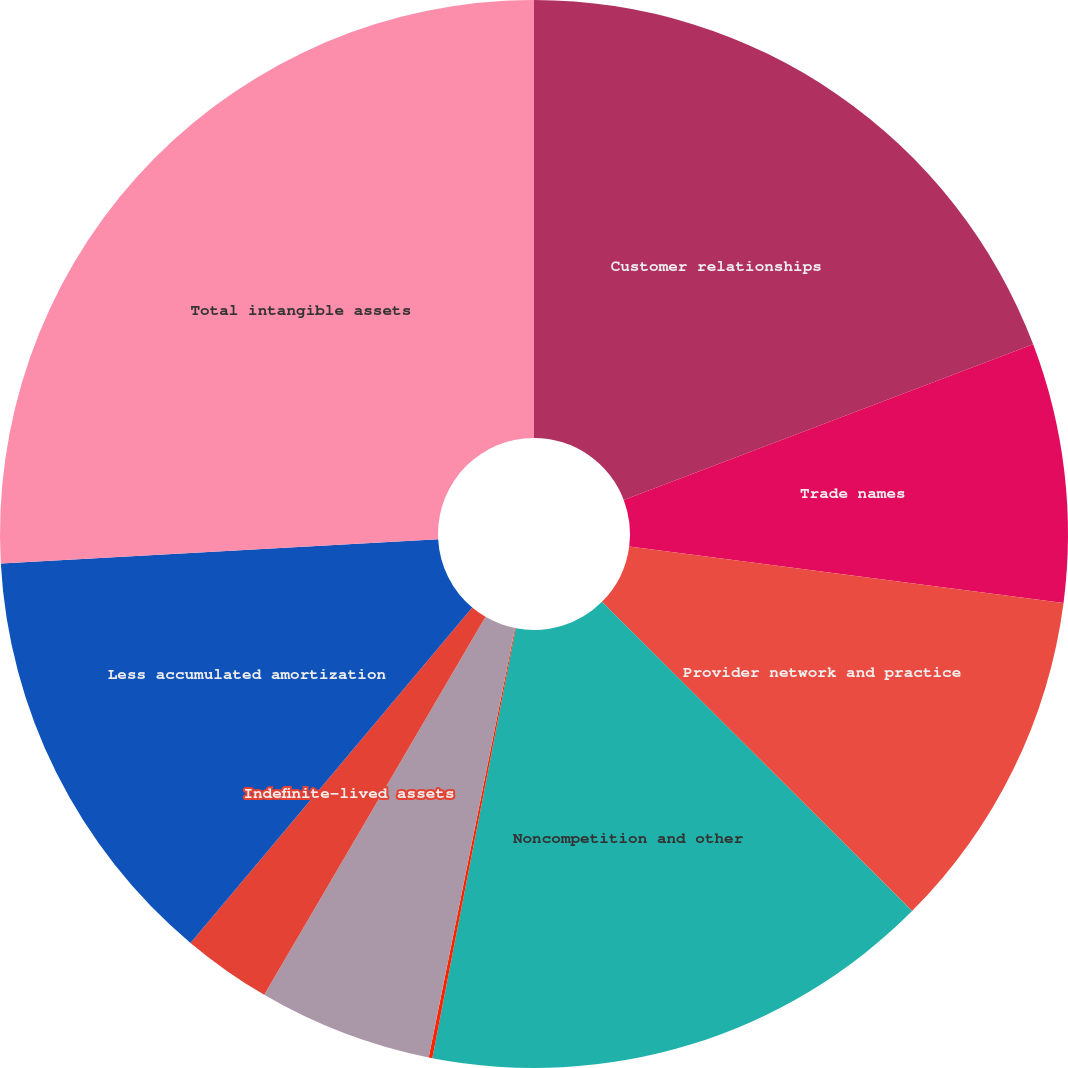<chart> <loc_0><loc_0><loc_500><loc_500><pie_chart><fcel>Customer relationships<fcel>Trade names<fcel>Provider network and practice<fcel>Noncompetition and other<fcel>Lease agreements<fcel>Deferred debt financing costs<fcel>Indefinite-lived assets<fcel>Less accumulated amortization<fcel>Total intangible assets<nl><fcel>19.22%<fcel>7.84%<fcel>10.42%<fcel>15.57%<fcel>0.11%<fcel>5.27%<fcel>2.69%<fcel>13.0%<fcel>25.88%<nl></chart> 